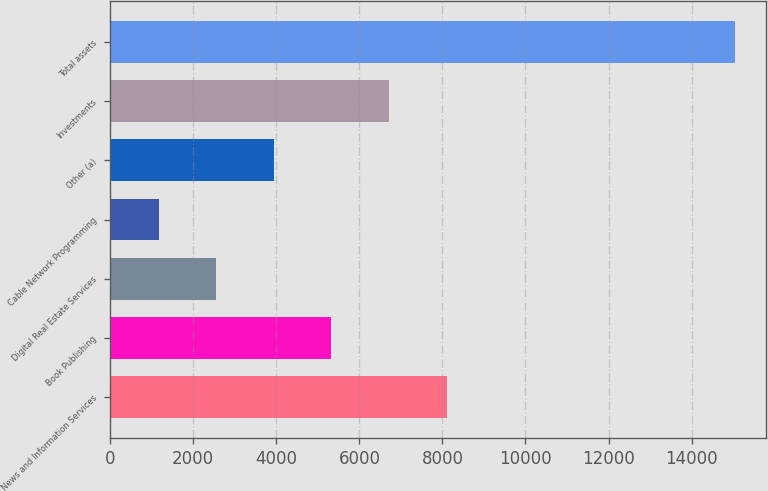Convert chart to OTSL. <chart><loc_0><loc_0><loc_500><loc_500><bar_chart><fcel>News and Information Services<fcel>Book Publishing<fcel>Digital Real Estate Services<fcel>Cable Network Programming<fcel>Other (a)<fcel>Investments<fcel>Total assets<nl><fcel>8099<fcel>5324.6<fcel>2550.2<fcel>1163<fcel>3937.4<fcel>6711.8<fcel>15035<nl></chart> 